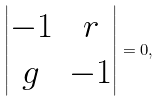Convert formula to latex. <formula><loc_0><loc_0><loc_500><loc_500>\begin{vmatrix} - 1 & r \\ g & - 1 \end{vmatrix} = 0 ,</formula> 